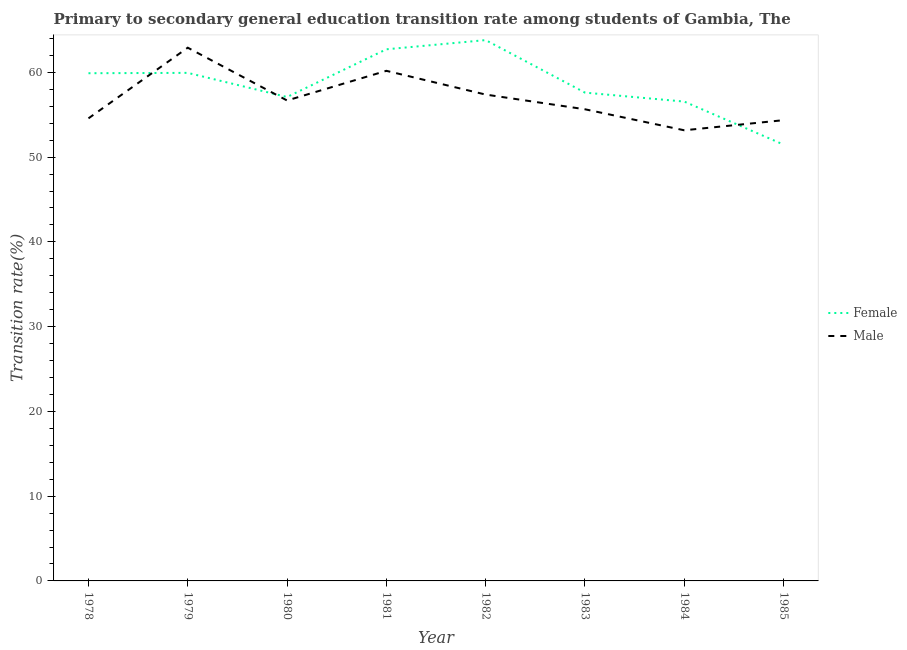How many different coloured lines are there?
Your answer should be compact. 2. Is the number of lines equal to the number of legend labels?
Ensure brevity in your answer.  Yes. What is the transition rate among female students in 1981?
Your response must be concise. 62.72. Across all years, what is the maximum transition rate among male students?
Provide a short and direct response. 62.91. Across all years, what is the minimum transition rate among female students?
Ensure brevity in your answer.  51.48. In which year was the transition rate among male students minimum?
Offer a terse response. 1984. What is the total transition rate among male students in the graph?
Your answer should be compact. 454.89. What is the difference between the transition rate among male students in 1981 and that in 1985?
Make the answer very short. 5.82. What is the difference between the transition rate among male students in 1982 and the transition rate among female students in 1984?
Give a very brief answer. 0.83. What is the average transition rate among male students per year?
Your answer should be very brief. 56.86. In the year 1978, what is the difference between the transition rate among female students and transition rate among male students?
Keep it short and to the point. 5.32. What is the ratio of the transition rate among female students in 1980 to that in 1985?
Offer a terse response. 1.11. Is the transition rate among male students in 1979 less than that in 1984?
Keep it short and to the point. No. What is the difference between the highest and the second highest transition rate among male students?
Your answer should be very brief. 2.73. What is the difference between the highest and the lowest transition rate among female students?
Your response must be concise. 12.33. Is the sum of the transition rate among female students in 1980 and 1984 greater than the maximum transition rate among male students across all years?
Your response must be concise. Yes. Does the transition rate among female students monotonically increase over the years?
Your answer should be very brief. No. Is the transition rate among male students strictly greater than the transition rate among female students over the years?
Give a very brief answer. No. Is the transition rate among male students strictly less than the transition rate among female students over the years?
Provide a short and direct response. No. How many years are there in the graph?
Offer a terse response. 8. What is the difference between two consecutive major ticks on the Y-axis?
Offer a very short reply. 10. Does the graph contain any zero values?
Give a very brief answer. No. Does the graph contain grids?
Your answer should be very brief. No. How are the legend labels stacked?
Offer a terse response. Vertical. What is the title of the graph?
Provide a succinct answer. Primary to secondary general education transition rate among students of Gambia, The. What is the label or title of the X-axis?
Your response must be concise. Year. What is the label or title of the Y-axis?
Ensure brevity in your answer.  Transition rate(%). What is the Transition rate(%) in Female in 1978?
Offer a very short reply. 59.9. What is the Transition rate(%) of Male in 1978?
Offer a very short reply. 54.57. What is the Transition rate(%) of Female in 1979?
Ensure brevity in your answer.  59.94. What is the Transition rate(%) in Male in 1979?
Keep it short and to the point. 62.91. What is the Transition rate(%) of Female in 1980?
Keep it short and to the point. 57.09. What is the Transition rate(%) in Male in 1980?
Your answer should be very brief. 56.68. What is the Transition rate(%) of Female in 1981?
Provide a succinct answer. 62.72. What is the Transition rate(%) of Male in 1981?
Your answer should be compact. 60.18. What is the Transition rate(%) of Female in 1982?
Provide a succinct answer. 63.8. What is the Transition rate(%) in Male in 1982?
Your answer should be compact. 57.38. What is the Transition rate(%) in Female in 1983?
Make the answer very short. 57.61. What is the Transition rate(%) of Male in 1983?
Make the answer very short. 55.64. What is the Transition rate(%) of Female in 1984?
Ensure brevity in your answer.  56.55. What is the Transition rate(%) of Male in 1984?
Provide a short and direct response. 53.17. What is the Transition rate(%) in Female in 1985?
Provide a short and direct response. 51.48. What is the Transition rate(%) of Male in 1985?
Your response must be concise. 54.36. Across all years, what is the maximum Transition rate(%) in Female?
Your response must be concise. 63.8. Across all years, what is the maximum Transition rate(%) in Male?
Your answer should be very brief. 62.91. Across all years, what is the minimum Transition rate(%) in Female?
Your answer should be very brief. 51.48. Across all years, what is the minimum Transition rate(%) in Male?
Ensure brevity in your answer.  53.17. What is the total Transition rate(%) in Female in the graph?
Ensure brevity in your answer.  469.09. What is the total Transition rate(%) of Male in the graph?
Keep it short and to the point. 454.89. What is the difference between the Transition rate(%) in Female in 1978 and that in 1979?
Your response must be concise. -0.04. What is the difference between the Transition rate(%) of Male in 1978 and that in 1979?
Give a very brief answer. -8.34. What is the difference between the Transition rate(%) of Female in 1978 and that in 1980?
Give a very brief answer. 2.81. What is the difference between the Transition rate(%) in Male in 1978 and that in 1980?
Give a very brief answer. -2.11. What is the difference between the Transition rate(%) of Female in 1978 and that in 1981?
Keep it short and to the point. -2.82. What is the difference between the Transition rate(%) of Male in 1978 and that in 1981?
Your answer should be compact. -5.61. What is the difference between the Transition rate(%) in Female in 1978 and that in 1982?
Your response must be concise. -3.91. What is the difference between the Transition rate(%) of Male in 1978 and that in 1982?
Ensure brevity in your answer.  -2.8. What is the difference between the Transition rate(%) in Female in 1978 and that in 1983?
Give a very brief answer. 2.29. What is the difference between the Transition rate(%) of Male in 1978 and that in 1983?
Offer a terse response. -1.07. What is the difference between the Transition rate(%) of Female in 1978 and that in 1984?
Keep it short and to the point. 3.35. What is the difference between the Transition rate(%) in Male in 1978 and that in 1984?
Provide a succinct answer. 1.41. What is the difference between the Transition rate(%) of Female in 1978 and that in 1985?
Make the answer very short. 8.42. What is the difference between the Transition rate(%) in Male in 1978 and that in 1985?
Offer a very short reply. 0.21. What is the difference between the Transition rate(%) of Female in 1979 and that in 1980?
Offer a very short reply. 2.85. What is the difference between the Transition rate(%) of Male in 1979 and that in 1980?
Offer a very short reply. 6.23. What is the difference between the Transition rate(%) in Female in 1979 and that in 1981?
Offer a very short reply. -2.78. What is the difference between the Transition rate(%) of Male in 1979 and that in 1981?
Keep it short and to the point. 2.73. What is the difference between the Transition rate(%) in Female in 1979 and that in 1982?
Your response must be concise. -3.87. What is the difference between the Transition rate(%) of Male in 1979 and that in 1982?
Ensure brevity in your answer.  5.53. What is the difference between the Transition rate(%) of Female in 1979 and that in 1983?
Keep it short and to the point. 2.33. What is the difference between the Transition rate(%) of Male in 1979 and that in 1983?
Your answer should be very brief. 7.27. What is the difference between the Transition rate(%) of Female in 1979 and that in 1984?
Keep it short and to the point. 3.39. What is the difference between the Transition rate(%) in Male in 1979 and that in 1984?
Provide a short and direct response. 9.74. What is the difference between the Transition rate(%) of Female in 1979 and that in 1985?
Ensure brevity in your answer.  8.46. What is the difference between the Transition rate(%) of Male in 1979 and that in 1985?
Provide a succinct answer. 8.55. What is the difference between the Transition rate(%) of Female in 1980 and that in 1981?
Your response must be concise. -5.63. What is the difference between the Transition rate(%) of Male in 1980 and that in 1981?
Your response must be concise. -3.5. What is the difference between the Transition rate(%) in Female in 1980 and that in 1982?
Ensure brevity in your answer.  -6.71. What is the difference between the Transition rate(%) in Male in 1980 and that in 1982?
Provide a succinct answer. -0.7. What is the difference between the Transition rate(%) of Female in 1980 and that in 1983?
Your answer should be compact. -0.52. What is the difference between the Transition rate(%) of Male in 1980 and that in 1983?
Give a very brief answer. 1.04. What is the difference between the Transition rate(%) of Female in 1980 and that in 1984?
Provide a succinct answer. 0.54. What is the difference between the Transition rate(%) in Male in 1980 and that in 1984?
Offer a very short reply. 3.52. What is the difference between the Transition rate(%) of Female in 1980 and that in 1985?
Make the answer very short. 5.61. What is the difference between the Transition rate(%) of Male in 1980 and that in 1985?
Give a very brief answer. 2.32. What is the difference between the Transition rate(%) of Female in 1981 and that in 1982?
Offer a terse response. -1.08. What is the difference between the Transition rate(%) of Male in 1981 and that in 1982?
Give a very brief answer. 2.8. What is the difference between the Transition rate(%) of Female in 1981 and that in 1983?
Keep it short and to the point. 5.11. What is the difference between the Transition rate(%) in Male in 1981 and that in 1983?
Your answer should be very brief. 4.54. What is the difference between the Transition rate(%) in Female in 1981 and that in 1984?
Give a very brief answer. 6.17. What is the difference between the Transition rate(%) in Male in 1981 and that in 1984?
Give a very brief answer. 7.01. What is the difference between the Transition rate(%) in Female in 1981 and that in 1985?
Provide a short and direct response. 11.24. What is the difference between the Transition rate(%) of Male in 1981 and that in 1985?
Make the answer very short. 5.82. What is the difference between the Transition rate(%) in Female in 1982 and that in 1983?
Offer a very short reply. 6.2. What is the difference between the Transition rate(%) in Male in 1982 and that in 1983?
Your answer should be very brief. 1.73. What is the difference between the Transition rate(%) of Female in 1982 and that in 1984?
Provide a short and direct response. 7.25. What is the difference between the Transition rate(%) in Male in 1982 and that in 1984?
Keep it short and to the point. 4.21. What is the difference between the Transition rate(%) of Female in 1982 and that in 1985?
Your answer should be compact. 12.33. What is the difference between the Transition rate(%) of Male in 1982 and that in 1985?
Provide a succinct answer. 3.02. What is the difference between the Transition rate(%) of Female in 1983 and that in 1984?
Your answer should be compact. 1.06. What is the difference between the Transition rate(%) in Male in 1983 and that in 1984?
Provide a short and direct response. 2.48. What is the difference between the Transition rate(%) of Female in 1983 and that in 1985?
Your answer should be very brief. 6.13. What is the difference between the Transition rate(%) of Male in 1983 and that in 1985?
Ensure brevity in your answer.  1.29. What is the difference between the Transition rate(%) in Female in 1984 and that in 1985?
Make the answer very short. 5.07. What is the difference between the Transition rate(%) in Male in 1984 and that in 1985?
Your answer should be very brief. -1.19. What is the difference between the Transition rate(%) of Female in 1978 and the Transition rate(%) of Male in 1979?
Your answer should be compact. -3.01. What is the difference between the Transition rate(%) in Female in 1978 and the Transition rate(%) in Male in 1980?
Offer a terse response. 3.22. What is the difference between the Transition rate(%) in Female in 1978 and the Transition rate(%) in Male in 1981?
Offer a very short reply. -0.28. What is the difference between the Transition rate(%) in Female in 1978 and the Transition rate(%) in Male in 1982?
Offer a terse response. 2.52. What is the difference between the Transition rate(%) in Female in 1978 and the Transition rate(%) in Male in 1983?
Keep it short and to the point. 4.25. What is the difference between the Transition rate(%) in Female in 1978 and the Transition rate(%) in Male in 1984?
Your answer should be compact. 6.73. What is the difference between the Transition rate(%) in Female in 1978 and the Transition rate(%) in Male in 1985?
Provide a succinct answer. 5.54. What is the difference between the Transition rate(%) of Female in 1979 and the Transition rate(%) of Male in 1980?
Provide a succinct answer. 3.26. What is the difference between the Transition rate(%) of Female in 1979 and the Transition rate(%) of Male in 1981?
Make the answer very short. -0.24. What is the difference between the Transition rate(%) in Female in 1979 and the Transition rate(%) in Male in 1982?
Your response must be concise. 2.56. What is the difference between the Transition rate(%) in Female in 1979 and the Transition rate(%) in Male in 1983?
Your answer should be very brief. 4.29. What is the difference between the Transition rate(%) in Female in 1979 and the Transition rate(%) in Male in 1984?
Your response must be concise. 6.77. What is the difference between the Transition rate(%) in Female in 1979 and the Transition rate(%) in Male in 1985?
Provide a short and direct response. 5.58. What is the difference between the Transition rate(%) in Female in 1980 and the Transition rate(%) in Male in 1981?
Make the answer very short. -3.09. What is the difference between the Transition rate(%) of Female in 1980 and the Transition rate(%) of Male in 1982?
Provide a succinct answer. -0.29. What is the difference between the Transition rate(%) of Female in 1980 and the Transition rate(%) of Male in 1983?
Offer a terse response. 1.45. What is the difference between the Transition rate(%) of Female in 1980 and the Transition rate(%) of Male in 1984?
Offer a terse response. 3.93. What is the difference between the Transition rate(%) of Female in 1980 and the Transition rate(%) of Male in 1985?
Keep it short and to the point. 2.73. What is the difference between the Transition rate(%) in Female in 1981 and the Transition rate(%) in Male in 1982?
Provide a short and direct response. 5.34. What is the difference between the Transition rate(%) of Female in 1981 and the Transition rate(%) of Male in 1983?
Provide a succinct answer. 7.08. What is the difference between the Transition rate(%) in Female in 1981 and the Transition rate(%) in Male in 1984?
Offer a very short reply. 9.55. What is the difference between the Transition rate(%) in Female in 1981 and the Transition rate(%) in Male in 1985?
Your answer should be very brief. 8.36. What is the difference between the Transition rate(%) of Female in 1982 and the Transition rate(%) of Male in 1983?
Ensure brevity in your answer.  8.16. What is the difference between the Transition rate(%) of Female in 1982 and the Transition rate(%) of Male in 1984?
Give a very brief answer. 10.64. What is the difference between the Transition rate(%) of Female in 1982 and the Transition rate(%) of Male in 1985?
Offer a terse response. 9.45. What is the difference between the Transition rate(%) in Female in 1983 and the Transition rate(%) in Male in 1984?
Make the answer very short. 4.44. What is the difference between the Transition rate(%) in Female in 1983 and the Transition rate(%) in Male in 1985?
Make the answer very short. 3.25. What is the difference between the Transition rate(%) in Female in 1984 and the Transition rate(%) in Male in 1985?
Provide a short and direct response. 2.19. What is the average Transition rate(%) of Female per year?
Ensure brevity in your answer.  58.64. What is the average Transition rate(%) of Male per year?
Your response must be concise. 56.86. In the year 1978, what is the difference between the Transition rate(%) of Female and Transition rate(%) of Male?
Keep it short and to the point. 5.32. In the year 1979, what is the difference between the Transition rate(%) of Female and Transition rate(%) of Male?
Give a very brief answer. -2.97. In the year 1980, what is the difference between the Transition rate(%) of Female and Transition rate(%) of Male?
Your response must be concise. 0.41. In the year 1981, what is the difference between the Transition rate(%) in Female and Transition rate(%) in Male?
Your response must be concise. 2.54. In the year 1982, what is the difference between the Transition rate(%) of Female and Transition rate(%) of Male?
Keep it short and to the point. 6.43. In the year 1983, what is the difference between the Transition rate(%) in Female and Transition rate(%) in Male?
Ensure brevity in your answer.  1.97. In the year 1984, what is the difference between the Transition rate(%) of Female and Transition rate(%) of Male?
Offer a very short reply. 3.39. In the year 1985, what is the difference between the Transition rate(%) of Female and Transition rate(%) of Male?
Offer a terse response. -2.88. What is the ratio of the Transition rate(%) of Female in 1978 to that in 1979?
Offer a very short reply. 1. What is the ratio of the Transition rate(%) of Male in 1978 to that in 1979?
Ensure brevity in your answer.  0.87. What is the ratio of the Transition rate(%) in Female in 1978 to that in 1980?
Your answer should be very brief. 1.05. What is the ratio of the Transition rate(%) of Male in 1978 to that in 1980?
Provide a succinct answer. 0.96. What is the ratio of the Transition rate(%) in Female in 1978 to that in 1981?
Your answer should be very brief. 0.95. What is the ratio of the Transition rate(%) of Male in 1978 to that in 1981?
Ensure brevity in your answer.  0.91. What is the ratio of the Transition rate(%) of Female in 1978 to that in 1982?
Provide a succinct answer. 0.94. What is the ratio of the Transition rate(%) in Male in 1978 to that in 1982?
Provide a succinct answer. 0.95. What is the ratio of the Transition rate(%) of Female in 1978 to that in 1983?
Offer a very short reply. 1.04. What is the ratio of the Transition rate(%) in Male in 1978 to that in 1983?
Your response must be concise. 0.98. What is the ratio of the Transition rate(%) in Female in 1978 to that in 1984?
Offer a very short reply. 1.06. What is the ratio of the Transition rate(%) of Male in 1978 to that in 1984?
Give a very brief answer. 1.03. What is the ratio of the Transition rate(%) of Female in 1978 to that in 1985?
Your answer should be very brief. 1.16. What is the ratio of the Transition rate(%) of Male in 1978 to that in 1985?
Give a very brief answer. 1. What is the ratio of the Transition rate(%) in Female in 1979 to that in 1980?
Your answer should be compact. 1.05. What is the ratio of the Transition rate(%) of Male in 1979 to that in 1980?
Offer a terse response. 1.11. What is the ratio of the Transition rate(%) of Female in 1979 to that in 1981?
Ensure brevity in your answer.  0.96. What is the ratio of the Transition rate(%) of Male in 1979 to that in 1981?
Offer a very short reply. 1.05. What is the ratio of the Transition rate(%) in Female in 1979 to that in 1982?
Give a very brief answer. 0.94. What is the ratio of the Transition rate(%) in Male in 1979 to that in 1982?
Your response must be concise. 1.1. What is the ratio of the Transition rate(%) in Female in 1979 to that in 1983?
Ensure brevity in your answer.  1.04. What is the ratio of the Transition rate(%) of Male in 1979 to that in 1983?
Ensure brevity in your answer.  1.13. What is the ratio of the Transition rate(%) of Female in 1979 to that in 1984?
Give a very brief answer. 1.06. What is the ratio of the Transition rate(%) in Male in 1979 to that in 1984?
Give a very brief answer. 1.18. What is the ratio of the Transition rate(%) of Female in 1979 to that in 1985?
Give a very brief answer. 1.16. What is the ratio of the Transition rate(%) in Male in 1979 to that in 1985?
Provide a short and direct response. 1.16. What is the ratio of the Transition rate(%) of Female in 1980 to that in 1981?
Offer a very short reply. 0.91. What is the ratio of the Transition rate(%) of Male in 1980 to that in 1981?
Offer a very short reply. 0.94. What is the ratio of the Transition rate(%) of Female in 1980 to that in 1982?
Your answer should be compact. 0.89. What is the ratio of the Transition rate(%) of Male in 1980 to that in 1982?
Make the answer very short. 0.99. What is the ratio of the Transition rate(%) in Female in 1980 to that in 1983?
Provide a short and direct response. 0.99. What is the ratio of the Transition rate(%) of Male in 1980 to that in 1983?
Give a very brief answer. 1.02. What is the ratio of the Transition rate(%) of Female in 1980 to that in 1984?
Your response must be concise. 1.01. What is the ratio of the Transition rate(%) in Male in 1980 to that in 1984?
Your response must be concise. 1.07. What is the ratio of the Transition rate(%) of Female in 1980 to that in 1985?
Ensure brevity in your answer.  1.11. What is the ratio of the Transition rate(%) in Male in 1980 to that in 1985?
Your response must be concise. 1.04. What is the ratio of the Transition rate(%) in Male in 1981 to that in 1982?
Keep it short and to the point. 1.05. What is the ratio of the Transition rate(%) of Female in 1981 to that in 1983?
Offer a terse response. 1.09. What is the ratio of the Transition rate(%) in Male in 1981 to that in 1983?
Your response must be concise. 1.08. What is the ratio of the Transition rate(%) of Female in 1981 to that in 1984?
Your answer should be very brief. 1.11. What is the ratio of the Transition rate(%) of Male in 1981 to that in 1984?
Make the answer very short. 1.13. What is the ratio of the Transition rate(%) in Female in 1981 to that in 1985?
Ensure brevity in your answer.  1.22. What is the ratio of the Transition rate(%) of Male in 1981 to that in 1985?
Your response must be concise. 1.11. What is the ratio of the Transition rate(%) of Female in 1982 to that in 1983?
Offer a very short reply. 1.11. What is the ratio of the Transition rate(%) of Male in 1982 to that in 1983?
Ensure brevity in your answer.  1.03. What is the ratio of the Transition rate(%) in Female in 1982 to that in 1984?
Provide a short and direct response. 1.13. What is the ratio of the Transition rate(%) in Male in 1982 to that in 1984?
Offer a terse response. 1.08. What is the ratio of the Transition rate(%) of Female in 1982 to that in 1985?
Your response must be concise. 1.24. What is the ratio of the Transition rate(%) in Male in 1982 to that in 1985?
Make the answer very short. 1.06. What is the ratio of the Transition rate(%) in Female in 1983 to that in 1984?
Ensure brevity in your answer.  1.02. What is the ratio of the Transition rate(%) in Male in 1983 to that in 1984?
Your answer should be compact. 1.05. What is the ratio of the Transition rate(%) in Female in 1983 to that in 1985?
Make the answer very short. 1.12. What is the ratio of the Transition rate(%) of Male in 1983 to that in 1985?
Your answer should be compact. 1.02. What is the ratio of the Transition rate(%) in Female in 1984 to that in 1985?
Make the answer very short. 1.1. What is the ratio of the Transition rate(%) in Male in 1984 to that in 1985?
Offer a very short reply. 0.98. What is the difference between the highest and the second highest Transition rate(%) of Female?
Ensure brevity in your answer.  1.08. What is the difference between the highest and the second highest Transition rate(%) of Male?
Provide a succinct answer. 2.73. What is the difference between the highest and the lowest Transition rate(%) in Female?
Ensure brevity in your answer.  12.33. What is the difference between the highest and the lowest Transition rate(%) in Male?
Make the answer very short. 9.74. 